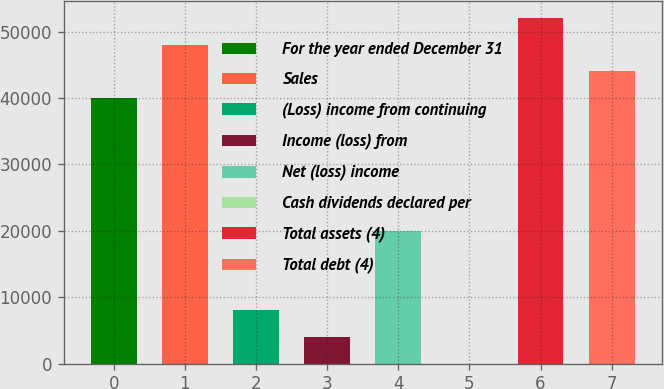<chart> <loc_0><loc_0><loc_500><loc_500><bar_chart><fcel>For the year ended December 31<fcel>Sales<fcel>(Loss) income from continuing<fcel>Income (loss) from<fcel>Net (loss) income<fcel>Cash dividends declared per<fcel>Total assets (4)<fcel>Total debt (4)<nl><fcel>40044<fcel>48052.7<fcel>8009.08<fcel>4004.72<fcel>20022.2<fcel>0.36<fcel>52057<fcel>44048.3<nl></chart> 